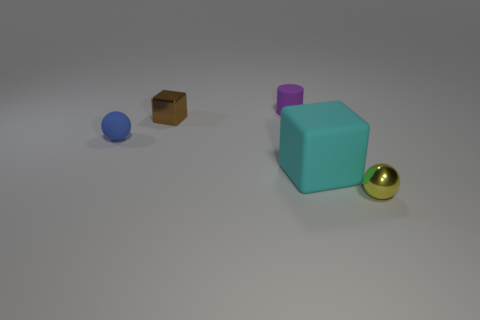Subtract all cyan cubes. How many cubes are left? 1 Subtract all blocks. How many objects are left? 3 Subtract all green blocks. Subtract all blue spheres. How many blocks are left? 2 Add 3 tiny rubber things. How many tiny rubber things are left? 5 Add 1 tiny blue rubber objects. How many tiny blue rubber objects exist? 2 Add 1 tiny brown metallic blocks. How many objects exist? 6 Subtract 0 red spheres. How many objects are left? 5 Subtract 1 spheres. How many spheres are left? 1 Subtract all yellow blocks. How many blue spheres are left? 1 Subtract all large rubber blocks. Subtract all tiny yellow shiny balls. How many objects are left? 3 